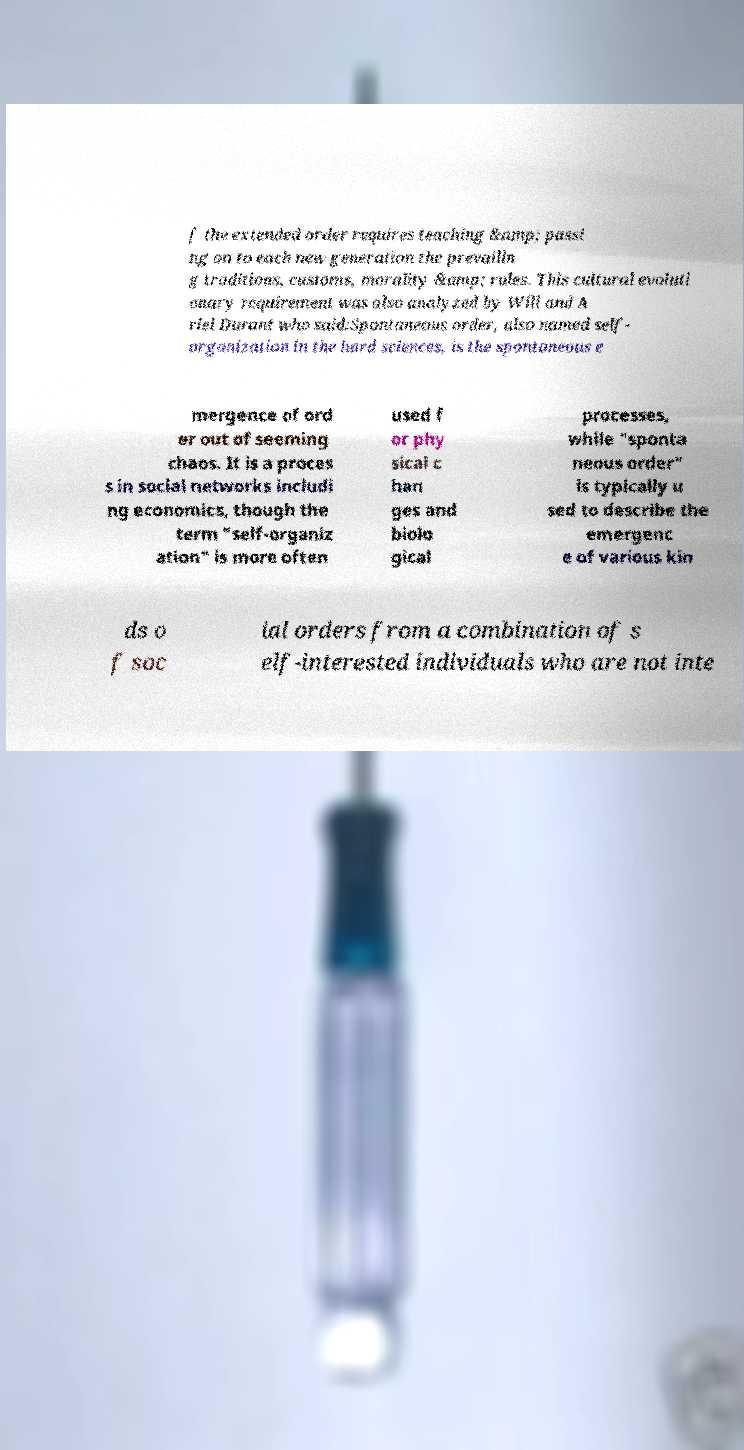Could you assist in decoding the text presented in this image and type it out clearly? f the extended order requires teaching &amp; passi ng on to each new generation the prevailin g traditions, customs, morality &amp; rules. This cultural evoluti onary requirement was also analyzed by Will and A riel Durant who said:Spontaneous order, also named self- organization in the hard sciences, is the spontaneous e mergence of ord er out of seeming chaos. It is a proces s in social networks includi ng economics, though the term "self-organiz ation" is more often used f or phy sical c han ges and biolo gical processes, while "sponta neous order" is typically u sed to describe the emergenc e of various kin ds o f soc ial orders from a combination of s elf-interested individuals who are not inte 